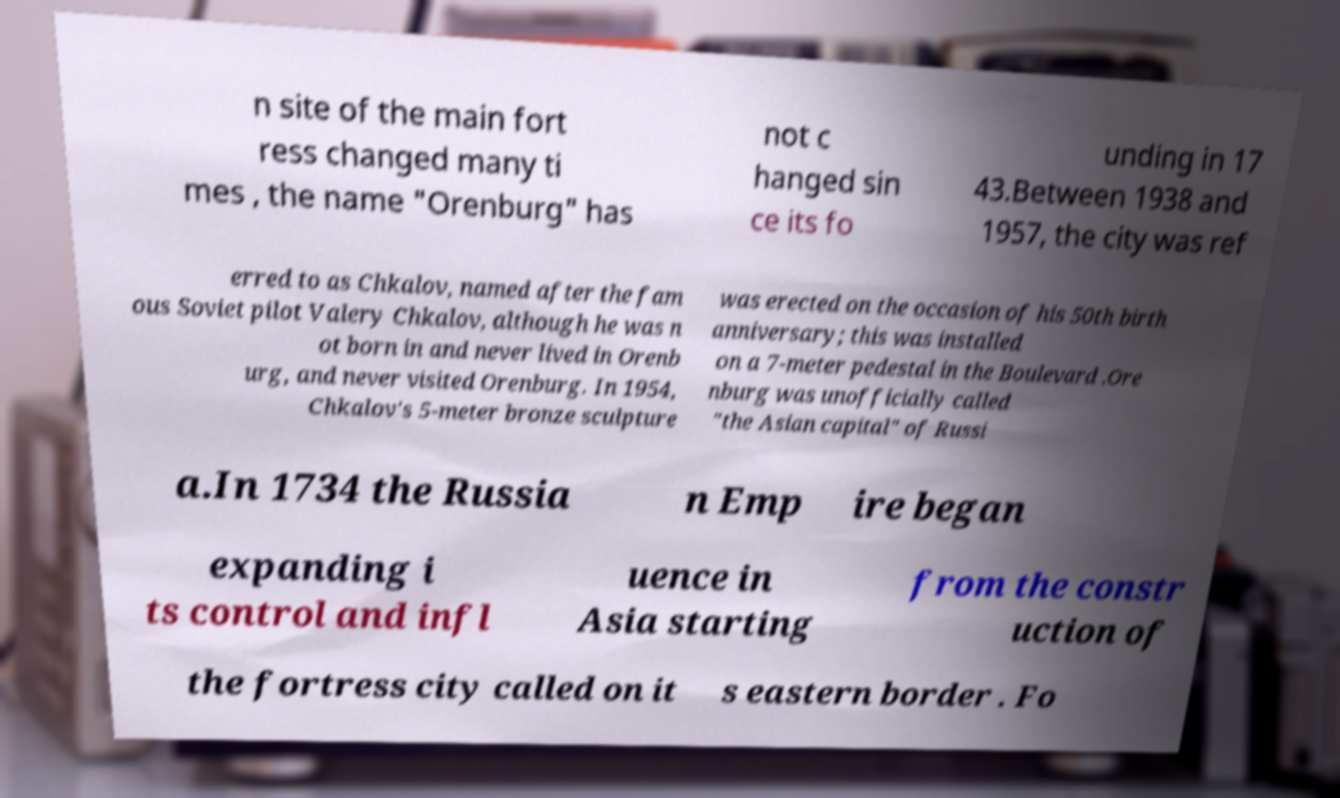For documentation purposes, I need the text within this image transcribed. Could you provide that? n site of the main fort ress changed many ti mes , the name "Orenburg" has not c hanged sin ce its fo unding in 17 43.Between 1938 and 1957, the city was ref erred to as Chkalov, named after the fam ous Soviet pilot Valery Chkalov, although he was n ot born in and never lived in Orenb urg, and never visited Orenburg. In 1954, Chkalov's 5-meter bronze sculpture was erected on the occasion of his 50th birth anniversary; this was installed on a 7-meter pedestal in the Boulevard .Ore nburg was unofficially called "the Asian capital" of Russi a.In 1734 the Russia n Emp ire began expanding i ts control and infl uence in Asia starting from the constr uction of the fortress city called on it s eastern border . Fo 